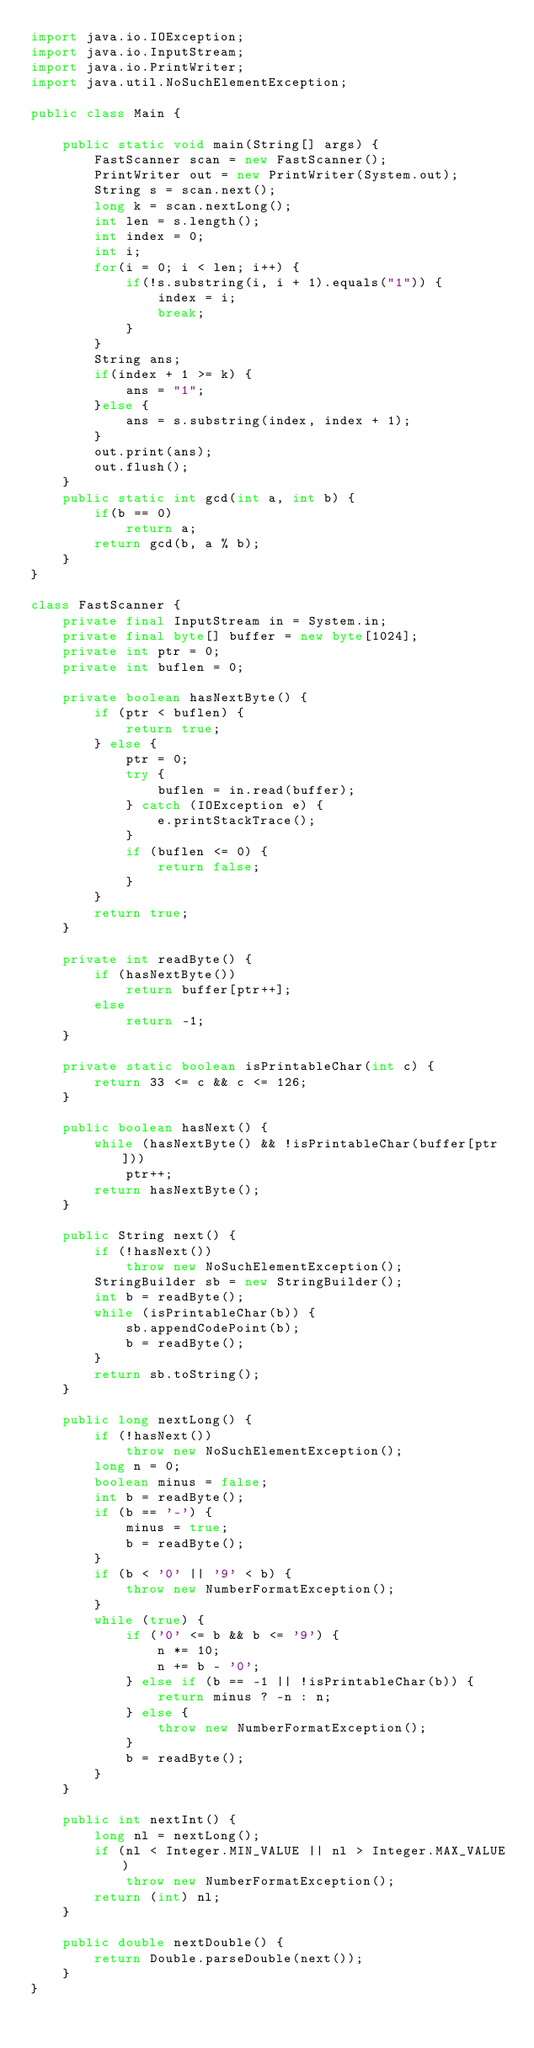Convert code to text. <code><loc_0><loc_0><loc_500><loc_500><_Java_>import java.io.IOException;
import java.io.InputStream;
import java.io.PrintWriter;
import java.util.NoSuchElementException;

public class Main {

	public static void main(String[] args) {
		FastScanner scan = new FastScanner();
		PrintWriter out = new PrintWriter(System.out);
		String s = scan.next();
		long k = scan.nextLong();
		int len = s.length();
		int index = 0;
		int i;
		for(i = 0; i < len; i++) {
			if(!s.substring(i, i + 1).equals("1")) {
				index = i;
				break;
			}
		}
		String ans;
		if(index + 1 >= k) {
			ans = "1";
		}else {
			ans = s.substring(index, index + 1);
		}
		out.print(ans);
		out.flush();
	}
	public static int gcd(int a, int b) {
		if(b == 0)
			return a;
		return gcd(b, a % b);
	}
}

class FastScanner {
	private final InputStream in = System.in;
	private final byte[] buffer = new byte[1024];
	private int ptr = 0;
	private int buflen = 0;

	private boolean hasNextByte() {
		if (ptr < buflen) {
			return true;
		} else {
			ptr = 0;
			try {
				buflen = in.read(buffer);
			} catch (IOException e) {
				e.printStackTrace();
			}
			if (buflen <= 0) {
				return false;
			}
		}
		return true;
	}

	private int readByte() {
		if (hasNextByte())
			return buffer[ptr++];
		else
			return -1;
	}

	private static boolean isPrintableChar(int c) {
		return 33 <= c && c <= 126;
	}

	public boolean hasNext() {
		while (hasNextByte() && !isPrintableChar(buffer[ptr]))
			ptr++;
		return hasNextByte();
	}

	public String next() {
		if (!hasNext())
			throw new NoSuchElementException();
		StringBuilder sb = new StringBuilder();
		int b = readByte();
		while (isPrintableChar(b)) {
			sb.appendCodePoint(b);
			b = readByte();
		}
		return sb.toString();
	}

	public long nextLong() {
		if (!hasNext())
			throw new NoSuchElementException();
		long n = 0;
		boolean minus = false;
		int b = readByte();
		if (b == '-') {
			minus = true;
			b = readByte();
		}
		if (b < '0' || '9' < b) {
			throw new NumberFormatException();
		}
		while (true) {
			if ('0' <= b && b <= '9') {
				n *= 10;
				n += b - '0';
			} else if (b == -1 || !isPrintableChar(b)) {
				return minus ? -n : n;
			} else {
				throw new NumberFormatException();
			}
			b = readByte();
		}
	}

	public int nextInt() {
		long nl = nextLong();
		if (nl < Integer.MIN_VALUE || nl > Integer.MAX_VALUE)
			throw new NumberFormatException();
		return (int) nl;
	}

	public double nextDouble() {
		return Double.parseDouble(next());
	}
}
</code> 